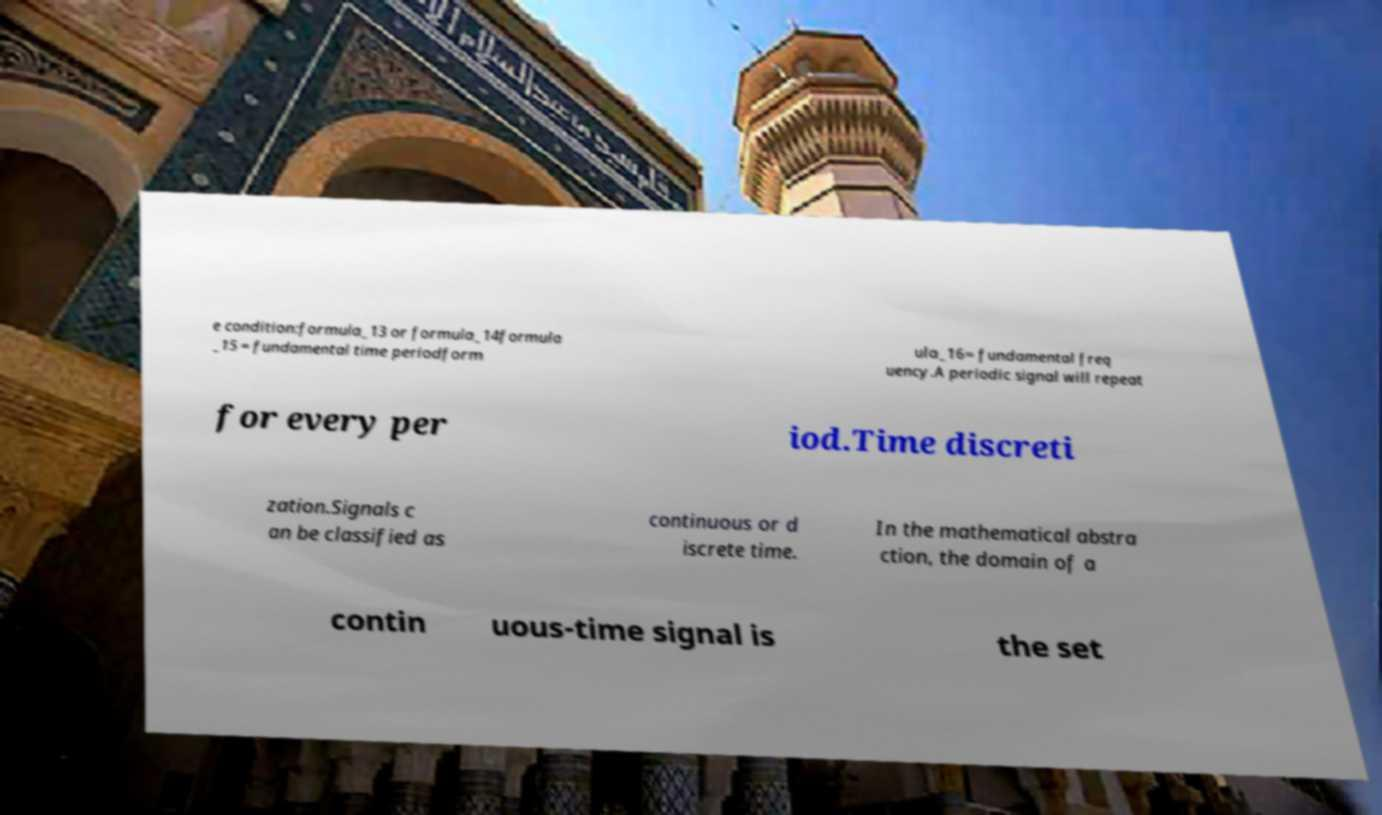There's text embedded in this image that I need extracted. Can you transcribe it verbatim? e condition:formula_13 or formula_14formula _15 = fundamental time periodform ula_16= fundamental freq uency.A periodic signal will repeat for every per iod.Time discreti zation.Signals c an be classified as continuous or d iscrete time. In the mathematical abstra ction, the domain of a contin uous-time signal is the set 